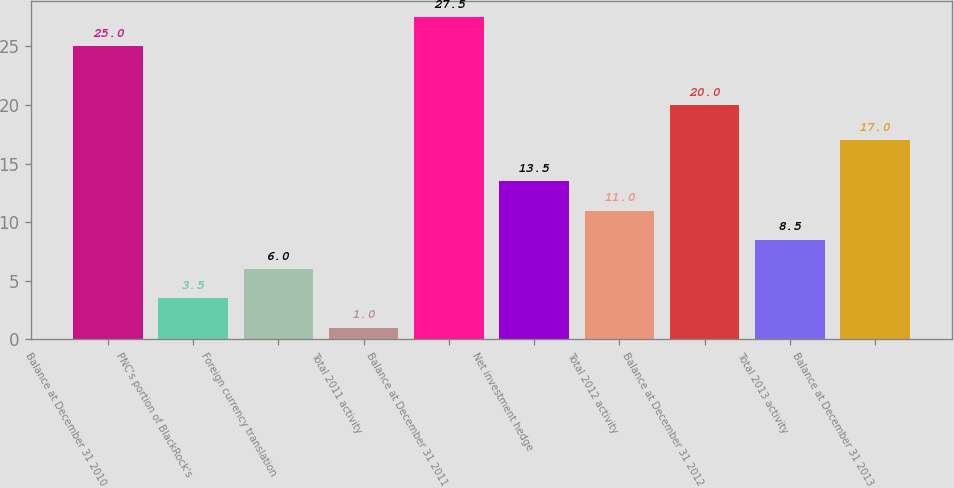Convert chart. <chart><loc_0><loc_0><loc_500><loc_500><bar_chart><fcel>Balance at December 31 2010<fcel>PNC's portion of BlackRock's<fcel>Foreign currency translation<fcel>Total 2011 activity<fcel>Balance at December 31 2011<fcel>Net investment hedge<fcel>Total 2012 activity<fcel>Balance at December 31 2012<fcel>Total 2013 activity<fcel>Balance at December 31 2013<nl><fcel>25<fcel>3.5<fcel>6<fcel>1<fcel>27.5<fcel>13.5<fcel>11<fcel>20<fcel>8.5<fcel>17<nl></chart> 